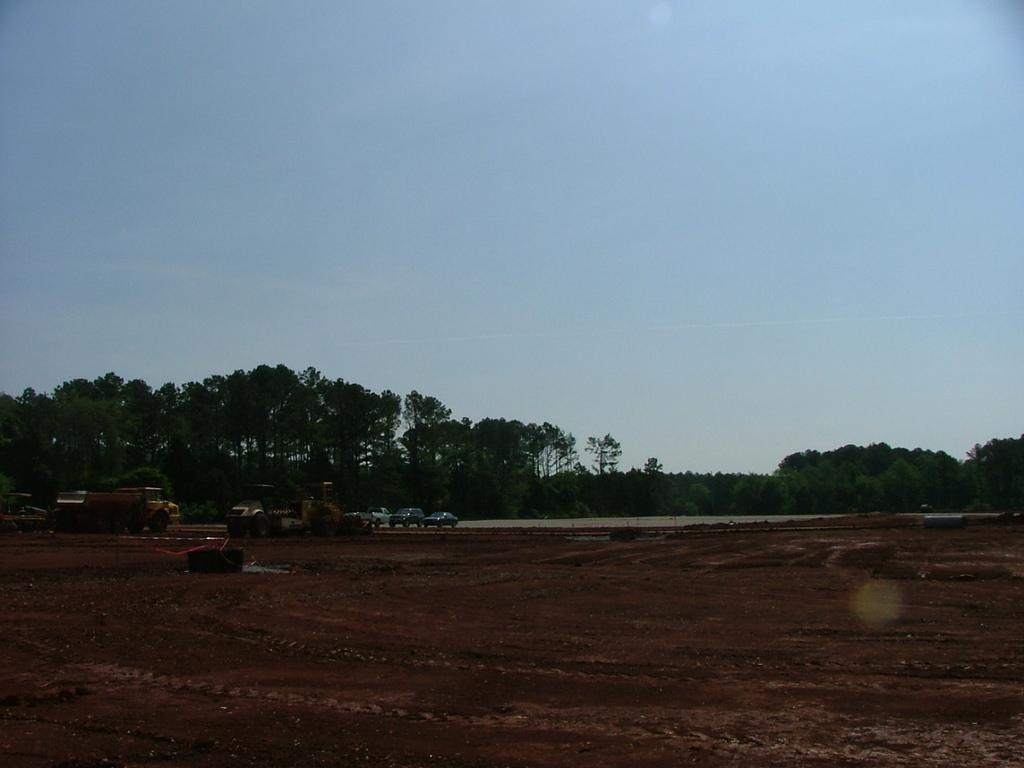What types of objects are on the ground in the image? There are vehicles on the ground in the image. What natural elements can be seen in the image? Trees are visible in the image. What part of the environment is visible in the image? The sky is visible in the image. What type of ship can be seen sailing in the sky in the image? There is no ship visible in the image, as it only features vehicles on the ground and trees and sky in the background. 